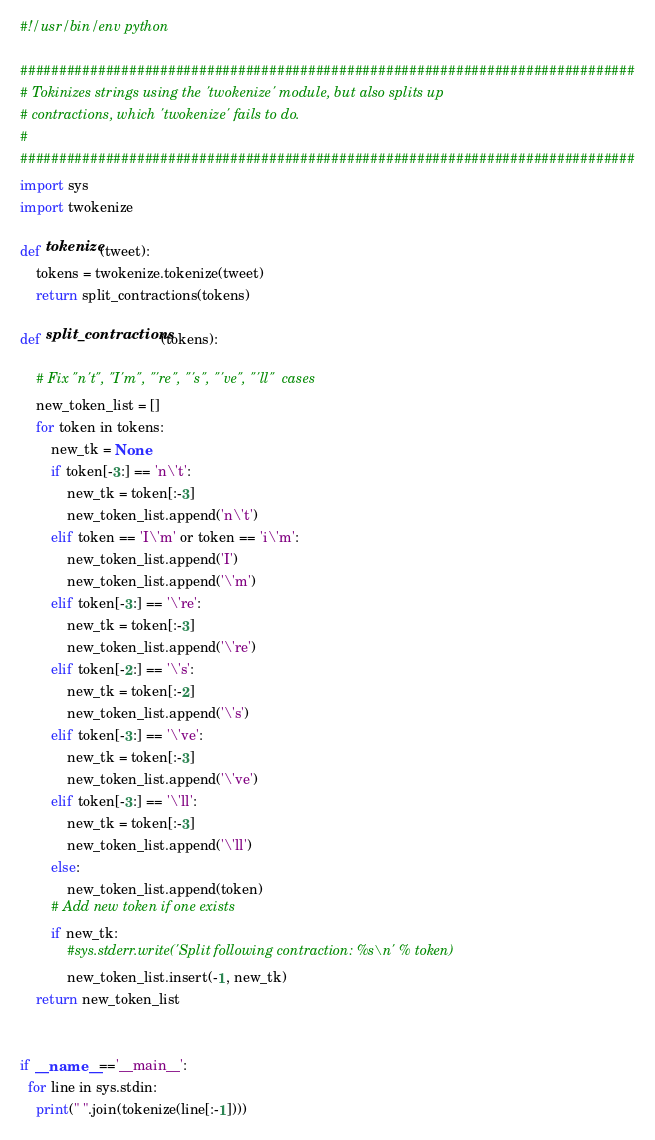Convert code to text. <code><loc_0><loc_0><loc_500><loc_500><_Python_>#!/usr/bin/env python

###############################################################################
# Tokinizes strings using the 'twokenize' module, but also splits up
# contractions, which 'twokenize' fails to do.
#
###############################################################################
import sys
import twokenize

def tokenize(tweet):
    tokens = twokenize.tokenize(tweet)
    return split_contractions(tokens)

def split_contractions(tokens):

    # Fix "n't", "I'm", "'re", "'s", "'ve", "'ll"  cases
    new_token_list = []
    for token in tokens:
        new_tk = None
        if token[-3:] == 'n\'t':
            new_tk = token[:-3]
            new_token_list.append('n\'t')
        elif token == 'I\'m' or token == 'i\'m':
            new_token_list.append('I')
            new_token_list.append('\'m')
        elif token[-3:] == '\'re':
            new_tk = token[:-3]
            new_token_list.append('\'re')
        elif token[-2:] == '\'s':
            new_tk = token[:-2]
            new_token_list.append('\'s')
        elif token[-3:] == '\'ve':
            new_tk = token[:-3]
            new_token_list.append('\'ve')
        elif token[-3:] == '\'ll':
            new_tk = token[:-3]
            new_token_list.append('\'ll')
        else:
            new_token_list.append(token)
        # Add new token if one exists  
        if new_tk:
            #sys.stderr.write('Split following contraction: %s\n' % token)
            new_token_list.insert(-1, new_tk)
    return new_token_list


if __name__=='__main__':
  for line in sys.stdin:
    print(" ".join(tokenize(line[:-1])))
</code> 